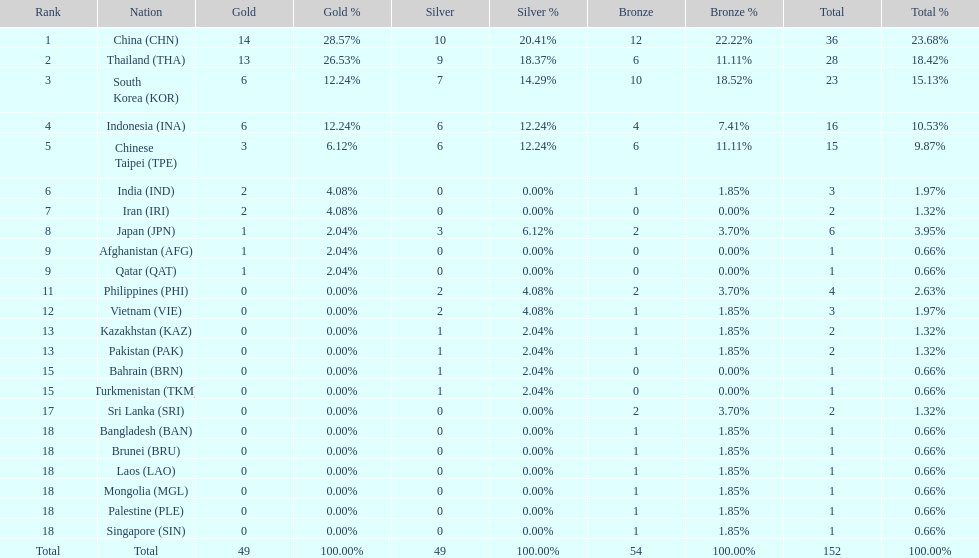What's the overall count of gold medals given out? 49. 